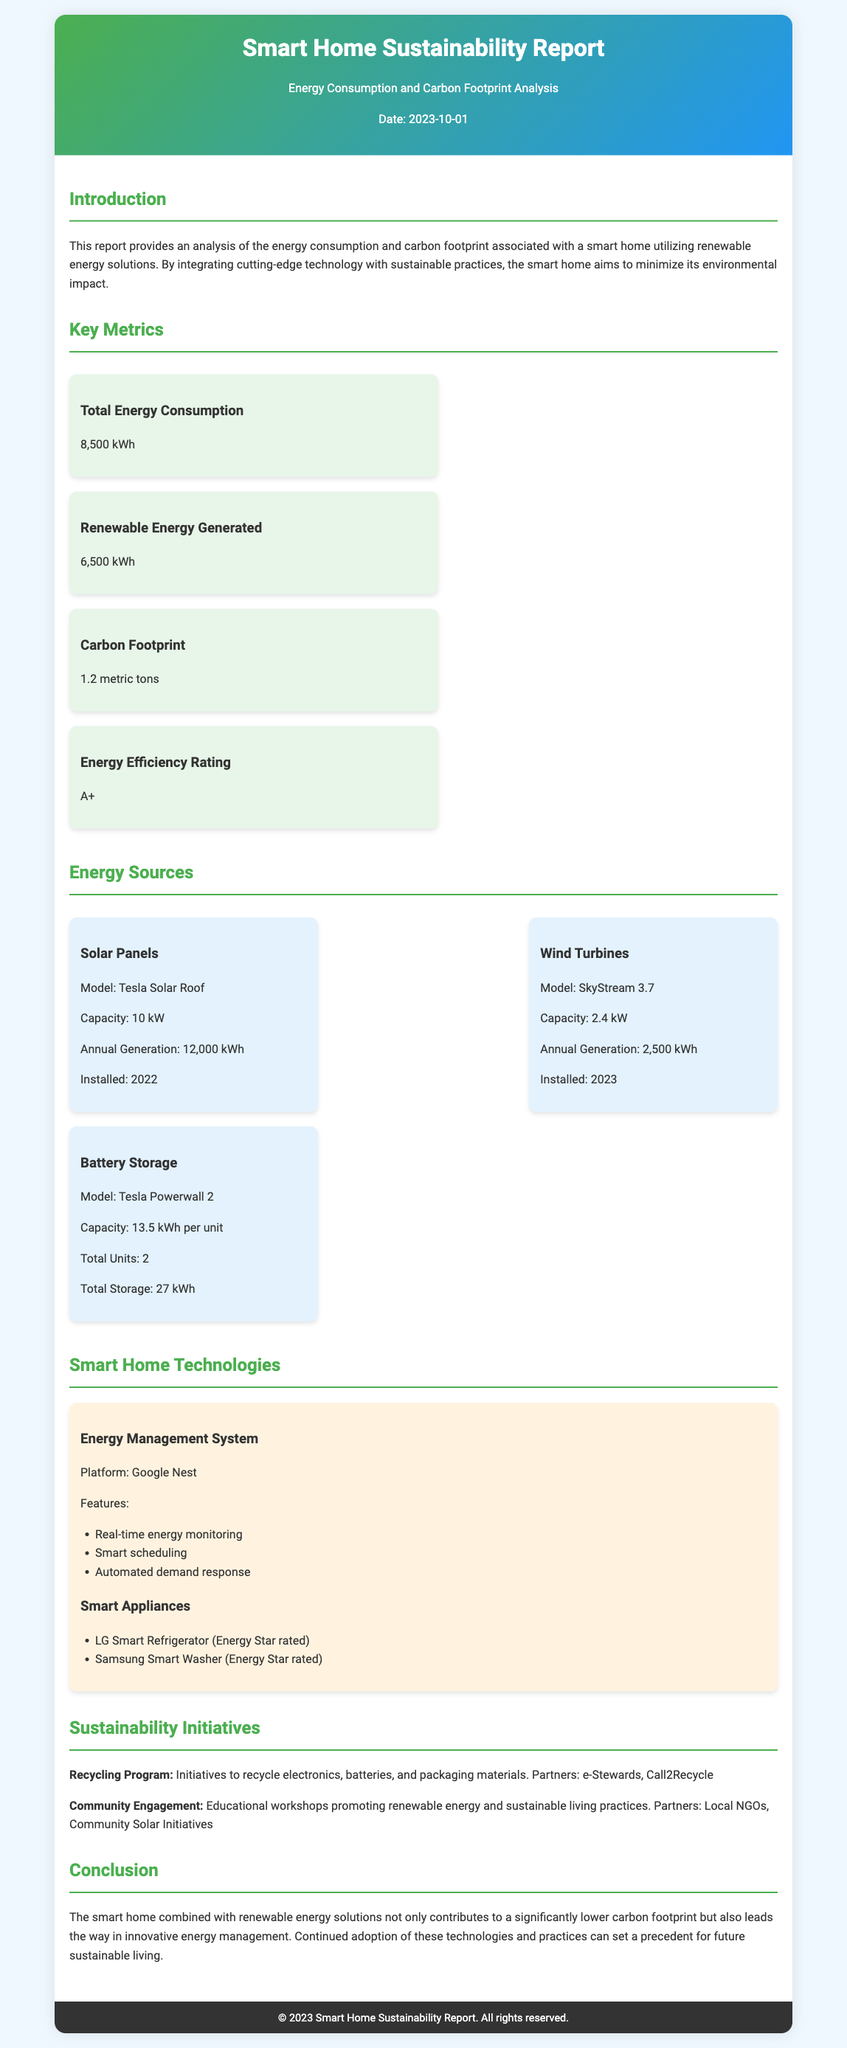what is the total energy consumption? The total energy consumption is specifically stated in the key metrics section of the document as 8,500 kWh.
Answer: 8,500 kWh what is the carbon footprint? The carbon footprint is mentioned in the key metrics and is measured as 1.2 metric tons.
Answer: 1.2 metric tons what is the capacity of the solar panels? The capacity of the solar panels, mentioned under Energy Sources, is 10 kW.
Answer: 10 kW which energy management system is used? The energy management system used in the smart home is stated as Google Nest in the smart home technologies section.
Answer: Google Nest how much renewable energy is generated? The renewable energy generated is listed in the key metrics as 6,500 kWh.
Answer: 6,500 kWh what is the energy efficiency rating? The energy efficiency rating of the smart home is specified as A+.
Answer: A+ which year were the wind turbines installed? The wind turbines are noted to have been installed in the year 2023.
Answer: 2023 what is the model of the battery storage? The model of the battery storage is indicated as Tesla Powerwall 2 in the energy sources section.
Answer: Tesla Powerwall 2 what initiatives are part of the sustainability program? The document mentions a recycling program and community engagement as part of the sustainability initiatives.
Answer: Recycling program and community engagement 